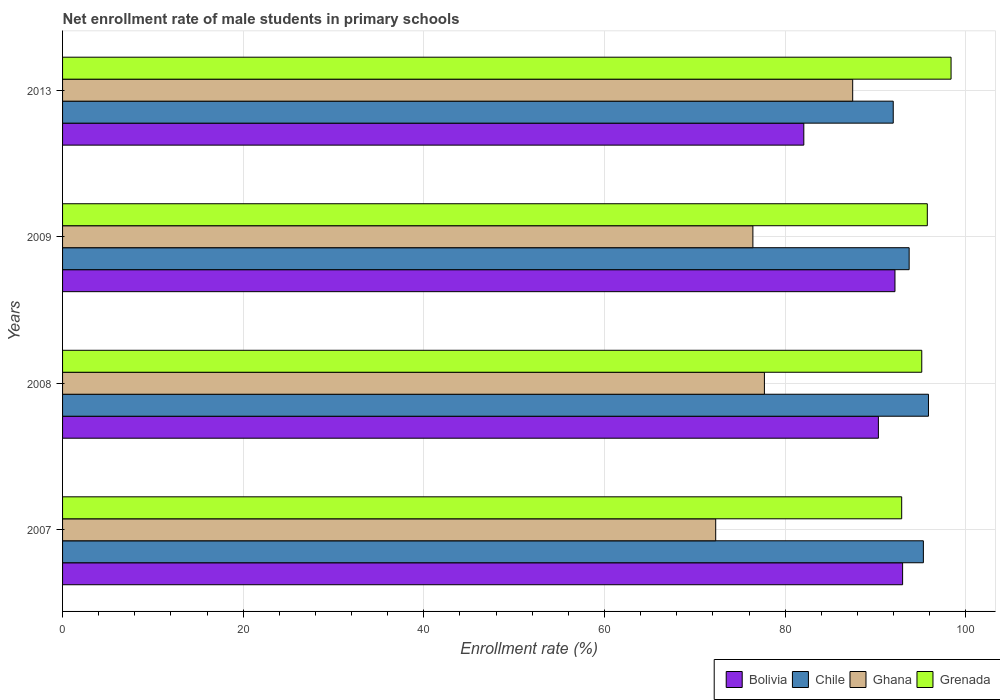How many groups of bars are there?
Your response must be concise. 4. Are the number of bars per tick equal to the number of legend labels?
Ensure brevity in your answer.  Yes. Are the number of bars on each tick of the Y-axis equal?
Give a very brief answer. Yes. How many bars are there on the 2nd tick from the top?
Make the answer very short. 4. How many bars are there on the 3rd tick from the bottom?
Your response must be concise. 4. In how many cases, is the number of bars for a given year not equal to the number of legend labels?
Provide a short and direct response. 0. What is the net enrollment rate of male students in primary schools in Grenada in 2013?
Offer a terse response. 98.37. Across all years, what is the maximum net enrollment rate of male students in primary schools in Bolivia?
Your answer should be very brief. 93.01. Across all years, what is the minimum net enrollment rate of male students in primary schools in Grenada?
Ensure brevity in your answer.  92.9. What is the total net enrollment rate of male students in primary schools in Grenada in the graph?
Make the answer very short. 382.14. What is the difference between the net enrollment rate of male students in primary schools in Chile in 2007 and that in 2009?
Your answer should be compact. 1.58. What is the difference between the net enrollment rate of male students in primary schools in Grenada in 2013 and the net enrollment rate of male students in primary schools in Bolivia in 2007?
Give a very brief answer. 5.37. What is the average net enrollment rate of male students in primary schools in Ghana per year?
Provide a short and direct response. 78.48. In the year 2009, what is the difference between the net enrollment rate of male students in primary schools in Chile and net enrollment rate of male students in primary schools in Bolivia?
Ensure brevity in your answer.  1.57. What is the ratio of the net enrollment rate of male students in primary schools in Grenada in 2008 to that in 2009?
Keep it short and to the point. 0.99. What is the difference between the highest and the second highest net enrollment rate of male students in primary schools in Bolivia?
Offer a very short reply. 0.84. What is the difference between the highest and the lowest net enrollment rate of male students in primary schools in Ghana?
Provide a succinct answer. 15.17. What does the 1st bar from the top in 2009 represents?
Offer a terse response. Grenada. What does the 4th bar from the bottom in 2007 represents?
Your response must be concise. Grenada. Is it the case that in every year, the sum of the net enrollment rate of male students in primary schools in Ghana and net enrollment rate of male students in primary schools in Grenada is greater than the net enrollment rate of male students in primary schools in Chile?
Offer a very short reply. Yes. How many bars are there?
Give a very brief answer. 16. Are all the bars in the graph horizontal?
Your response must be concise. Yes. How many years are there in the graph?
Offer a terse response. 4. Does the graph contain grids?
Offer a terse response. Yes. Where does the legend appear in the graph?
Offer a very short reply. Bottom right. How are the legend labels stacked?
Your response must be concise. Horizontal. What is the title of the graph?
Provide a succinct answer. Net enrollment rate of male students in primary schools. Does "Northern Mariana Islands" appear as one of the legend labels in the graph?
Ensure brevity in your answer.  No. What is the label or title of the X-axis?
Give a very brief answer. Enrollment rate (%). What is the Enrollment rate (%) in Bolivia in 2007?
Give a very brief answer. 93.01. What is the Enrollment rate (%) of Chile in 2007?
Your response must be concise. 95.31. What is the Enrollment rate (%) in Ghana in 2007?
Your answer should be very brief. 72.31. What is the Enrollment rate (%) of Grenada in 2007?
Provide a short and direct response. 92.9. What is the Enrollment rate (%) in Bolivia in 2008?
Your answer should be very brief. 90.33. What is the Enrollment rate (%) of Chile in 2008?
Give a very brief answer. 95.87. What is the Enrollment rate (%) in Ghana in 2008?
Ensure brevity in your answer.  77.7. What is the Enrollment rate (%) of Grenada in 2008?
Offer a terse response. 95.13. What is the Enrollment rate (%) in Bolivia in 2009?
Ensure brevity in your answer.  92.16. What is the Enrollment rate (%) of Chile in 2009?
Make the answer very short. 93.73. What is the Enrollment rate (%) of Ghana in 2009?
Keep it short and to the point. 76.43. What is the Enrollment rate (%) in Grenada in 2009?
Ensure brevity in your answer.  95.74. What is the Enrollment rate (%) of Bolivia in 2013?
Ensure brevity in your answer.  82.07. What is the Enrollment rate (%) in Chile in 2013?
Give a very brief answer. 91.97. What is the Enrollment rate (%) in Ghana in 2013?
Ensure brevity in your answer.  87.48. What is the Enrollment rate (%) of Grenada in 2013?
Your response must be concise. 98.37. Across all years, what is the maximum Enrollment rate (%) of Bolivia?
Provide a short and direct response. 93.01. Across all years, what is the maximum Enrollment rate (%) in Chile?
Provide a short and direct response. 95.87. Across all years, what is the maximum Enrollment rate (%) of Ghana?
Your answer should be very brief. 87.48. Across all years, what is the maximum Enrollment rate (%) of Grenada?
Give a very brief answer. 98.37. Across all years, what is the minimum Enrollment rate (%) of Bolivia?
Offer a very short reply. 82.07. Across all years, what is the minimum Enrollment rate (%) in Chile?
Your response must be concise. 91.97. Across all years, what is the minimum Enrollment rate (%) in Ghana?
Keep it short and to the point. 72.31. Across all years, what is the minimum Enrollment rate (%) in Grenada?
Offer a terse response. 92.9. What is the total Enrollment rate (%) in Bolivia in the graph?
Your answer should be very brief. 357.56. What is the total Enrollment rate (%) of Chile in the graph?
Provide a succinct answer. 376.87. What is the total Enrollment rate (%) in Ghana in the graph?
Ensure brevity in your answer.  313.92. What is the total Enrollment rate (%) of Grenada in the graph?
Offer a very short reply. 382.14. What is the difference between the Enrollment rate (%) of Bolivia in 2007 and that in 2008?
Ensure brevity in your answer.  2.68. What is the difference between the Enrollment rate (%) of Chile in 2007 and that in 2008?
Make the answer very short. -0.56. What is the difference between the Enrollment rate (%) of Ghana in 2007 and that in 2008?
Your response must be concise. -5.39. What is the difference between the Enrollment rate (%) in Grenada in 2007 and that in 2008?
Keep it short and to the point. -2.22. What is the difference between the Enrollment rate (%) in Bolivia in 2007 and that in 2009?
Give a very brief answer. 0.84. What is the difference between the Enrollment rate (%) of Chile in 2007 and that in 2009?
Provide a short and direct response. 1.58. What is the difference between the Enrollment rate (%) of Ghana in 2007 and that in 2009?
Give a very brief answer. -4.12. What is the difference between the Enrollment rate (%) of Grenada in 2007 and that in 2009?
Your response must be concise. -2.84. What is the difference between the Enrollment rate (%) of Bolivia in 2007 and that in 2013?
Your answer should be compact. 10.94. What is the difference between the Enrollment rate (%) in Chile in 2007 and that in 2013?
Your answer should be very brief. 3.34. What is the difference between the Enrollment rate (%) in Ghana in 2007 and that in 2013?
Keep it short and to the point. -15.17. What is the difference between the Enrollment rate (%) of Grenada in 2007 and that in 2013?
Make the answer very short. -5.47. What is the difference between the Enrollment rate (%) of Bolivia in 2008 and that in 2009?
Ensure brevity in your answer.  -1.84. What is the difference between the Enrollment rate (%) in Chile in 2008 and that in 2009?
Offer a very short reply. 2.14. What is the difference between the Enrollment rate (%) of Ghana in 2008 and that in 2009?
Keep it short and to the point. 1.27. What is the difference between the Enrollment rate (%) of Grenada in 2008 and that in 2009?
Your answer should be compact. -0.62. What is the difference between the Enrollment rate (%) in Bolivia in 2008 and that in 2013?
Offer a very short reply. 8.26. What is the difference between the Enrollment rate (%) in Chile in 2008 and that in 2013?
Ensure brevity in your answer.  3.9. What is the difference between the Enrollment rate (%) in Ghana in 2008 and that in 2013?
Your answer should be compact. -9.78. What is the difference between the Enrollment rate (%) of Grenada in 2008 and that in 2013?
Make the answer very short. -3.24. What is the difference between the Enrollment rate (%) in Bolivia in 2009 and that in 2013?
Keep it short and to the point. 10.09. What is the difference between the Enrollment rate (%) of Chile in 2009 and that in 2013?
Provide a succinct answer. 1.76. What is the difference between the Enrollment rate (%) in Ghana in 2009 and that in 2013?
Provide a succinct answer. -11.05. What is the difference between the Enrollment rate (%) in Grenada in 2009 and that in 2013?
Your answer should be compact. -2.63. What is the difference between the Enrollment rate (%) of Bolivia in 2007 and the Enrollment rate (%) of Chile in 2008?
Your answer should be very brief. -2.86. What is the difference between the Enrollment rate (%) in Bolivia in 2007 and the Enrollment rate (%) in Ghana in 2008?
Provide a short and direct response. 15.3. What is the difference between the Enrollment rate (%) in Bolivia in 2007 and the Enrollment rate (%) in Grenada in 2008?
Provide a succinct answer. -2.12. What is the difference between the Enrollment rate (%) of Chile in 2007 and the Enrollment rate (%) of Ghana in 2008?
Ensure brevity in your answer.  17.6. What is the difference between the Enrollment rate (%) in Chile in 2007 and the Enrollment rate (%) in Grenada in 2008?
Ensure brevity in your answer.  0.18. What is the difference between the Enrollment rate (%) of Ghana in 2007 and the Enrollment rate (%) of Grenada in 2008?
Offer a terse response. -22.81. What is the difference between the Enrollment rate (%) of Bolivia in 2007 and the Enrollment rate (%) of Chile in 2009?
Offer a terse response. -0.72. What is the difference between the Enrollment rate (%) in Bolivia in 2007 and the Enrollment rate (%) in Ghana in 2009?
Make the answer very short. 16.58. What is the difference between the Enrollment rate (%) of Bolivia in 2007 and the Enrollment rate (%) of Grenada in 2009?
Ensure brevity in your answer.  -2.74. What is the difference between the Enrollment rate (%) of Chile in 2007 and the Enrollment rate (%) of Ghana in 2009?
Keep it short and to the point. 18.88. What is the difference between the Enrollment rate (%) of Chile in 2007 and the Enrollment rate (%) of Grenada in 2009?
Offer a very short reply. -0.44. What is the difference between the Enrollment rate (%) in Ghana in 2007 and the Enrollment rate (%) in Grenada in 2009?
Your response must be concise. -23.43. What is the difference between the Enrollment rate (%) in Bolivia in 2007 and the Enrollment rate (%) in Chile in 2013?
Your response must be concise. 1.04. What is the difference between the Enrollment rate (%) of Bolivia in 2007 and the Enrollment rate (%) of Ghana in 2013?
Make the answer very short. 5.53. What is the difference between the Enrollment rate (%) of Bolivia in 2007 and the Enrollment rate (%) of Grenada in 2013?
Offer a very short reply. -5.37. What is the difference between the Enrollment rate (%) of Chile in 2007 and the Enrollment rate (%) of Ghana in 2013?
Your answer should be compact. 7.83. What is the difference between the Enrollment rate (%) of Chile in 2007 and the Enrollment rate (%) of Grenada in 2013?
Your answer should be very brief. -3.07. What is the difference between the Enrollment rate (%) in Ghana in 2007 and the Enrollment rate (%) in Grenada in 2013?
Give a very brief answer. -26.06. What is the difference between the Enrollment rate (%) in Bolivia in 2008 and the Enrollment rate (%) in Chile in 2009?
Provide a succinct answer. -3.4. What is the difference between the Enrollment rate (%) in Bolivia in 2008 and the Enrollment rate (%) in Ghana in 2009?
Give a very brief answer. 13.9. What is the difference between the Enrollment rate (%) in Bolivia in 2008 and the Enrollment rate (%) in Grenada in 2009?
Offer a terse response. -5.42. What is the difference between the Enrollment rate (%) of Chile in 2008 and the Enrollment rate (%) of Ghana in 2009?
Provide a short and direct response. 19.44. What is the difference between the Enrollment rate (%) in Chile in 2008 and the Enrollment rate (%) in Grenada in 2009?
Ensure brevity in your answer.  0.13. What is the difference between the Enrollment rate (%) in Ghana in 2008 and the Enrollment rate (%) in Grenada in 2009?
Provide a short and direct response. -18.04. What is the difference between the Enrollment rate (%) in Bolivia in 2008 and the Enrollment rate (%) in Chile in 2013?
Make the answer very short. -1.64. What is the difference between the Enrollment rate (%) in Bolivia in 2008 and the Enrollment rate (%) in Ghana in 2013?
Keep it short and to the point. 2.85. What is the difference between the Enrollment rate (%) in Bolivia in 2008 and the Enrollment rate (%) in Grenada in 2013?
Your response must be concise. -8.05. What is the difference between the Enrollment rate (%) of Chile in 2008 and the Enrollment rate (%) of Ghana in 2013?
Give a very brief answer. 8.39. What is the difference between the Enrollment rate (%) of Chile in 2008 and the Enrollment rate (%) of Grenada in 2013?
Offer a very short reply. -2.5. What is the difference between the Enrollment rate (%) of Ghana in 2008 and the Enrollment rate (%) of Grenada in 2013?
Keep it short and to the point. -20.67. What is the difference between the Enrollment rate (%) of Bolivia in 2009 and the Enrollment rate (%) of Chile in 2013?
Ensure brevity in your answer.  0.19. What is the difference between the Enrollment rate (%) of Bolivia in 2009 and the Enrollment rate (%) of Ghana in 2013?
Make the answer very short. 4.68. What is the difference between the Enrollment rate (%) of Bolivia in 2009 and the Enrollment rate (%) of Grenada in 2013?
Keep it short and to the point. -6.21. What is the difference between the Enrollment rate (%) of Chile in 2009 and the Enrollment rate (%) of Ghana in 2013?
Offer a terse response. 6.25. What is the difference between the Enrollment rate (%) of Chile in 2009 and the Enrollment rate (%) of Grenada in 2013?
Ensure brevity in your answer.  -4.64. What is the difference between the Enrollment rate (%) of Ghana in 2009 and the Enrollment rate (%) of Grenada in 2013?
Provide a short and direct response. -21.94. What is the average Enrollment rate (%) of Bolivia per year?
Give a very brief answer. 89.39. What is the average Enrollment rate (%) of Chile per year?
Your answer should be compact. 94.22. What is the average Enrollment rate (%) of Ghana per year?
Provide a succinct answer. 78.48. What is the average Enrollment rate (%) in Grenada per year?
Ensure brevity in your answer.  95.54. In the year 2007, what is the difference between the Enrollment rate (%) of Bolivia and Enrollment rate (%) of Chile?
Provide a succinct answer. -2.3. In the year 2007, what is the difference between the Enrollment rate (%) of Bolivia and Enrollment rate (%) of Ghana?
Make the answer very short. 20.69. In the year 2007, what is the difference between the Enrollment rate (%) of Bolivia and Enrollment rate (%) of Grenada?
Keep it short and to the point. 0.1. In the year 2007, what is the difference between the Enrollment rate (%) in Chile and Enrollment rate (%) in Ghana?
Provide a short and direct response. 22.99. In the year 2007, what is the difference between the Enrollment rate (%) in Chile and Enrollment rate (%) in Grenada?
Offer a very short reply. 2.4. In the year 2007, what is the difference between the Enrollment rate (%) in Ghana and Enrollment rate (%) in Grenada?
Your response must be concise. -20.59. In the year 2008, what is the difference between the Enrollment rate (%) in Bolivia and Enrollment rate (%) in Chile?
Your answer should be very brief. -5.54. In the year 2008, what is the difference between the Enrollment rate (%) in Bolivia and Enrollment rate (%) in Ghana?
Your answer should be compact. 12.62. In the year 2008, what is the difference between the Enrollment rate (%) in Bolivia and Enrollment rate (%) in Grenada?
Your answer should be compact. -4.8. In the year 2008, what is the difference between the Enrollment rate (%) in Chile and Enrollment rate (%) in Ghana?
Provide a succinct answer. 18.16. In the year 2008, what is the difference between the Enrollment rate (%) of Chile and Enrollment rate (%) of Grenada?
Your answer should be very brief. 0.74. In the year 2008, what is the difference between the Enrollment rate (%) in Ghana and Enrollment rate (%) in Grenada?
Your answer should be compact. -17.42. In the year 2009, what is the difference between the Enrollment rate (%) in Bolivia and Enrollment rate (%) in Chile?
Provide a short and direct response. -1.57. In the year 2009, what is the difference between the Enrollment rate (%) in Bolivia and Enrollment rate (%) in Ghana?
Ensure brevity in your answer.  15.73. In the year 2009, what is the difference between the Enrollment rate (%) in Bolivia and Enrollment rate (%) in Grenada?
Ensure brevity in your answer.  -3.58. In the year 2009, what is the difference between the Enrollment rate (%) of Chile and Enrollment rate (%) of Ghana?
Ensure brevity in your answer.  17.3. In the year 2009, what is the difference between the Enrollment rate (%) of Chile and Enrollment rate (%) of Grenada?
Provide a short and direct response. -2.01. In the year 2009, what is the difference between the Enrollment rate (%) in Ghana and Enrollment rate (%) in Grenada?
Offer a very short reply. -19.31. In the year 2013, what is the difference between the Enrollment rate (%) of Bolivia and Enrollment rate (%) of Chile?
Your answer should be compact. -9.9. In the year 2013, what is the difference between the Enrollment rate (%) of Bolivia and Enrollment rate (%) of Ghana?
Offer a very short reply. -5.41. In the year 2013, what is the difference between the Enrollment rate (%) of Bolivia and Enrollment rate (%) of Grenada?
Provide a succinct answer. -16.3. In the year 2013, what is the difference between the Enrollment rate (%) of Chile and Enrollment rate (%) of Ghana?
Provide a short and direct response. 4.49. In the year 2013, what is the difference between the Enrollment rate (%) in Chile and Enrollment rate (%) in Grenada?
Your answer should be very brief. -6.4. In the year 2013, what is the difference between the Enrollment rate (%) in Ghana and Enrollment rate (%) in Grenada?
Your answer should be very brief. -10.89. What is the ratio of the Enrollment rate (%) in Bolivia in 2007 to that in 2008?
Your response must be concise. 1.03. What is the ratio of the Enrollment rate (%) in Ghana in 2007 to that in 2008?
Give a very brief answer. 0.93. What is the ratio of the Enrollment rate (%) of Grenada in 2007 to that in 2008?
Your answer should be very brief. 0.98. What is the ratio of the Enrollment rate (%) in Bolivia in 2007 to that in 2009?
Provide a short and direct response. 1.01. What is the ratio of the Enrollment rate (%) of Chile in 2007 to that in 2009?
Offer a very short reply. 1.02. What is the ratio of the Enrollment rate (%) in Ghana in 2007 to that in 2009?
Offer a terse response. 0.95. What is the ratio of the Enrollment rate (%) of Grenada in 2007 to that in 2009?
Ensure brevity in your answer.  0.97. What is the ratio of the Enrollment rate (%) of Bolivia in 2007 to that in 2013?
Keep it short and to the point. 1.13. What is the ratio of the Enrollment rate (%) of Chile in 2007 to that in 2013?
Ensure brevity in your answer.  1.04. What is the ratio of the Enrollment rate (%) of Ghana in 2007 to that in 2013?
Offer a terse response. 0.83. What is the ratio of the Enrollment rate (%) in Grenada in 2007 to that in 2013?
Give a very brief answer. 0.94. What is the ratio of the Enrollment rate (%) in Bolivia in 2008 to that in 2009?
Your answer should be very brief. 0.98. What is the ratio of the Enrollment rate (%) in Chile in 2008 to that in 2009?
Offer a terse response. 1.02. What is the ratio of the Enrollment rate (%) of Ghana in 2008 to that in 2009?
Give a very brief answer. 1.02. What is the ratio of the Enrollment rate (%) in Grenada in 2008 to that in 2009?
Offer a very short reply. 0.99. What is the ratio of the Enrollment rate (%) of Bolivia in 2008 to that in 2013?
Give a very brief answer. 1.1. What is the ratio of the Enrollment rate (%) of Chile in 2008 to that in 2013?
Ensure brevity in your answer.  1.04. What is the ratio of the Enrollment rate (%) of Ghana in 2008 to that in 2013?
Your answer should be compact. 0.89. What is the ratio of the Enrollment rate (%) of Bolivia in 2009 to that in 2013?
Provide a short and direct response. 1.12. What is the ratio of the Enrollment rate (%) of Chile in 2009 to that in 2013?
Offer a very short reply. 1.02. What is the ratio of the Enrollment rate (%) in Ghana in 2009 to that in 2013?
Ensure brevity in your answer.  0.87. What is the ratio of the Enrollment rate (%) in Grenada in 2009 to that in 2013?
Give a very brief answer. 0.97. What is the difference between the highest and the second highest Enrollment rate (%) of Bolivia?
Give a very brief answer. 0.84. What is the difference between the highest and the second highest Enrollment rate (%) of Chile?
Your answer should be very brief. 0.56. What is the difference between the highest and the second highest Enrollment rate (%) of Ghana?
Offer a very short reply. 9.78. What is the difference between the highest and the second highest Enrollment rate (%) in Grenada?
Ensure brevity in your answer.  2.63. What is the difference between the highest and the lowest Enrollment rate (%) in Bolivia?
Keep it short and to the point. 10.94. What is the difference between the highest and the lowest Enrollment rate (%) in Chile?
Give a very brief answer. 3.9. What is the difference between the highest and the lowest Enrollment rate (%) of Ghana?
Offer a very short reply. 15.17. What is the difference between the highest and the lowest Enrollment rate (%) of Grenada?
Keep it short and to the point. 5.47. 